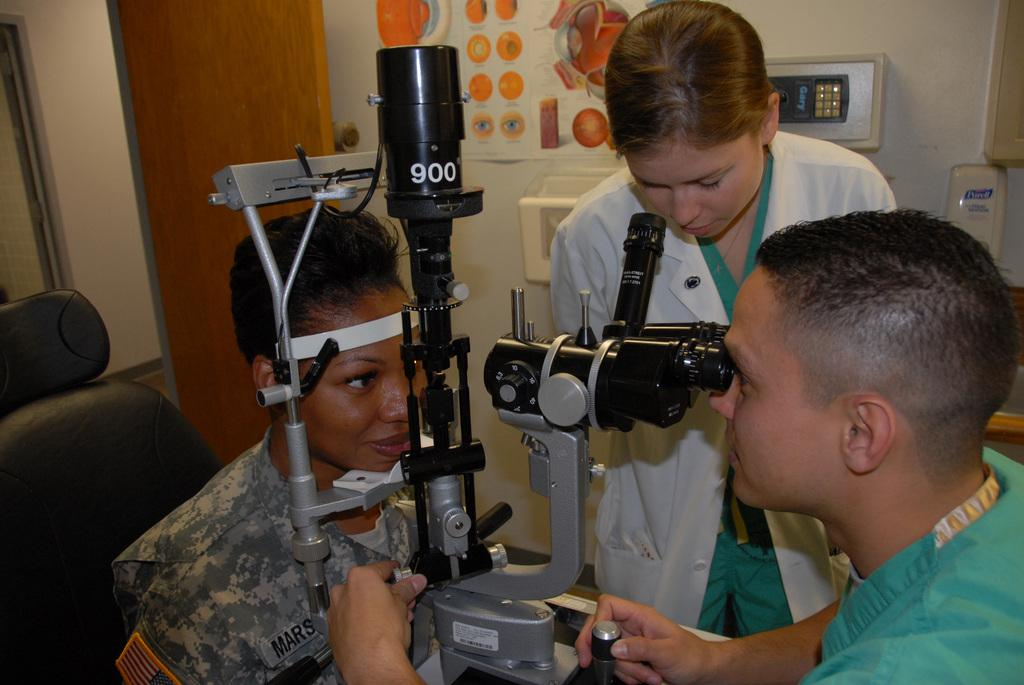How many people are present in the image? There are three people in the image. What is the position of one of the people? One person is sitting on a chair. What can be seen between two of the people? There is equipment visible between two of the people. What is in the background of the image? There is a poster on a wall in the background. What type of shop can be seen in the image? There is no shop present in the image. What is the relation between the three people in the image? The relation between the three people cannot be determined from the image alone, as there is not enough information provided. 